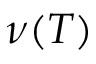<formula> <loc_0><loc_0><loc_500><loc_500>\nu ( T )</formula> 